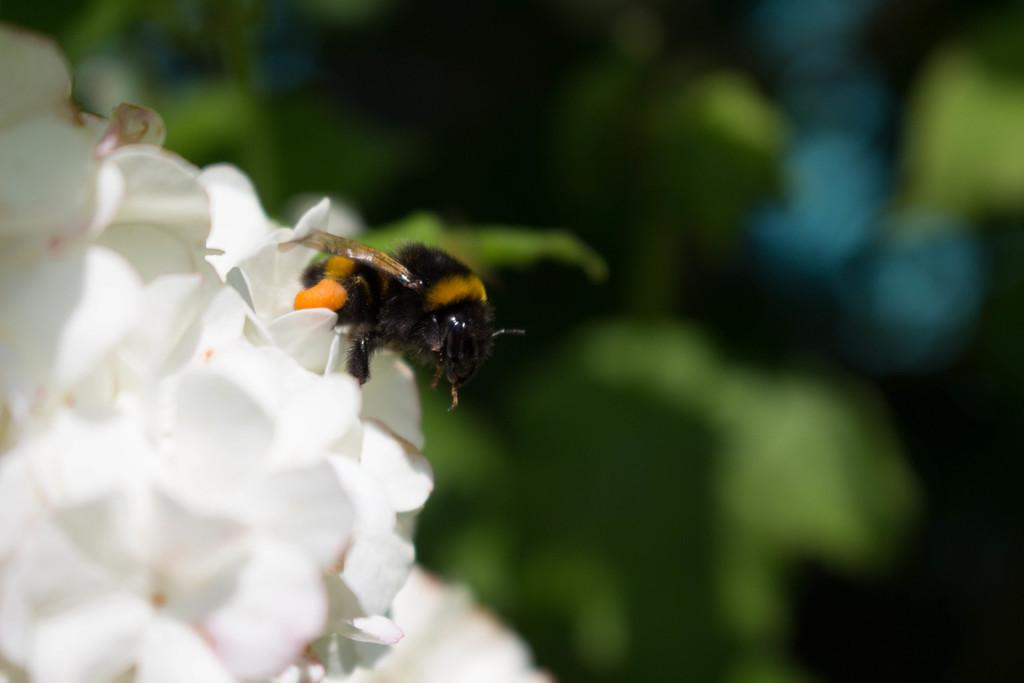What type of flowers can be seen in the image? There are white flowers in the image. Is there any other living organism present on the flowers? Yes, there is a honey bee on one of the flowers. Can you describe the background of the image? The background of the image is blurred. How does the image reflect the wealth of the person who took it? The image does not provide any information about the wealth of the person who took it. The focus is on the white flowers and the honey bee. 